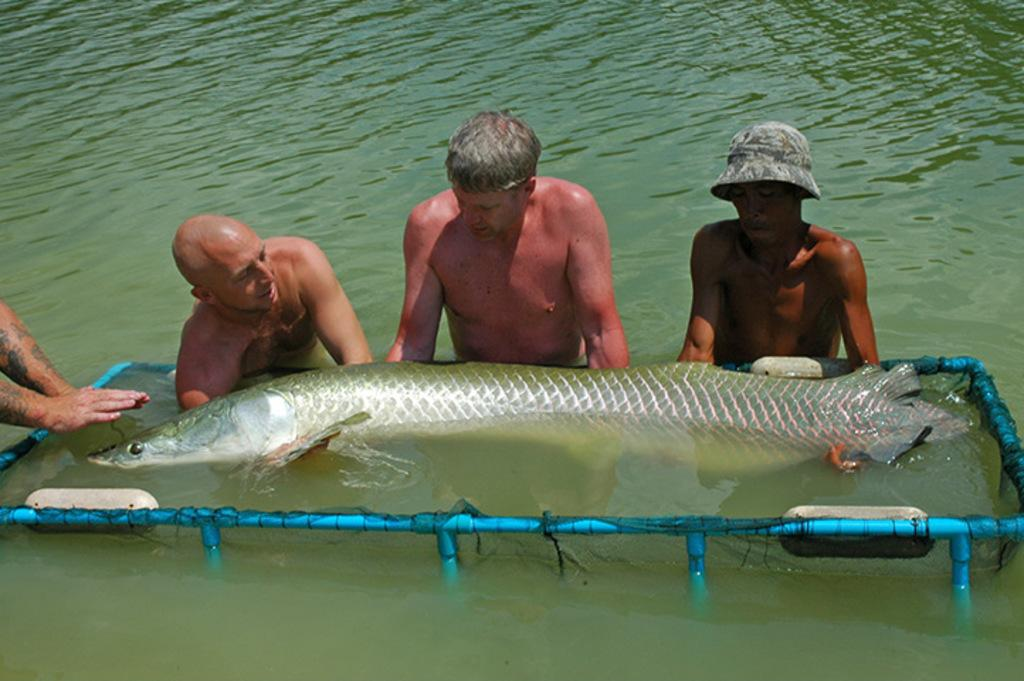How many people are in the water in the image? There are three men in the water in the image. What else can be seen in the water besides the men? There are fish in the image. What objects are present in the image that might be used for fishing? There is a net and rods in the image. Whose hands are visible in the image? A person's hands are visible in the image. What type of soda is being served in the image? There is no soda present in the image; it features three men in the water, fish, a net, rods, and a person's hands. 